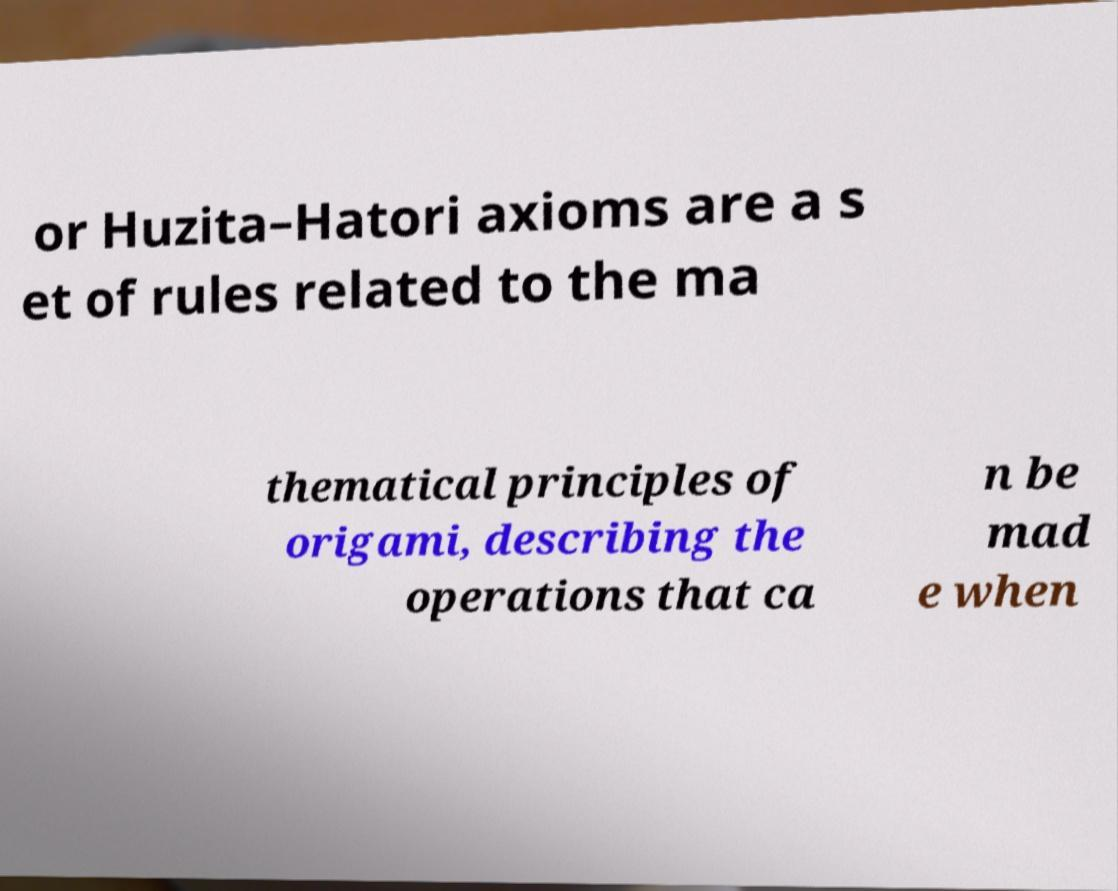Please read and relay the text visible in this image. What does it say? or Huzita–Hatori axioms are a s et of rules related to the ma thematical principles of origami, describing the operations that ca n be mad e when 